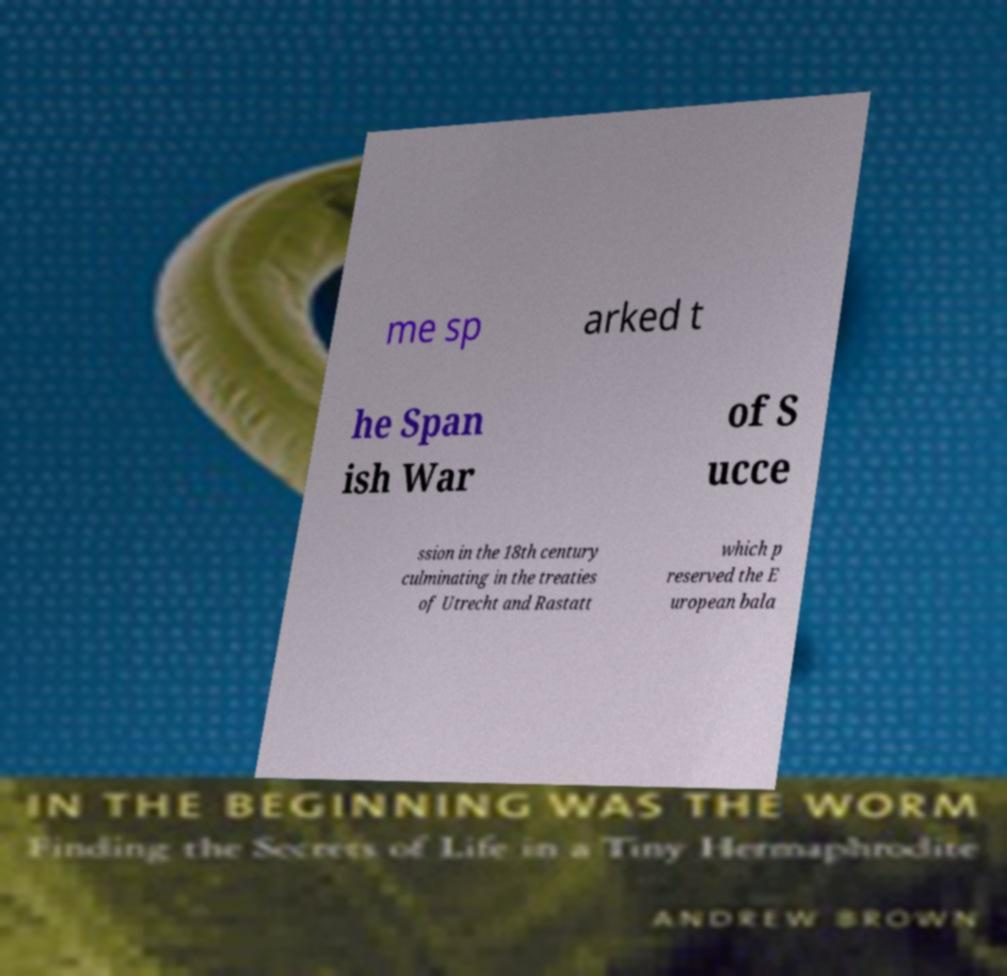There's text embedded in this image that I need extracted. Can you transcribe it verbatim? me sp arked t he Span ish War of S ucce ssion in the 18th century culminating in the treaties of Utrecht and Rastatt which p reserved the E uropean bala 